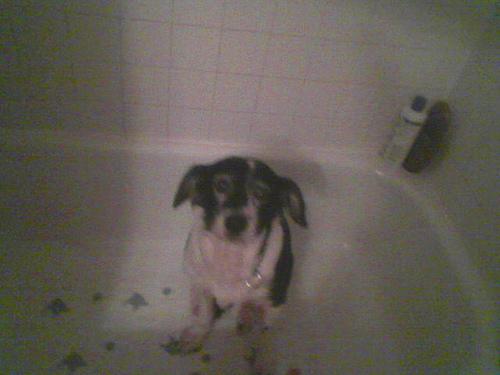Is the dog getting a bath?
Be succinct. Yes. Where is the dog at?
Be succinct. Bathtub. What is in the sink?
Keep it brief. Dog. Is the dog wearing a collar?
Write a very short answer. Yes. Is this a bulldog?
Concise answer only. No. 